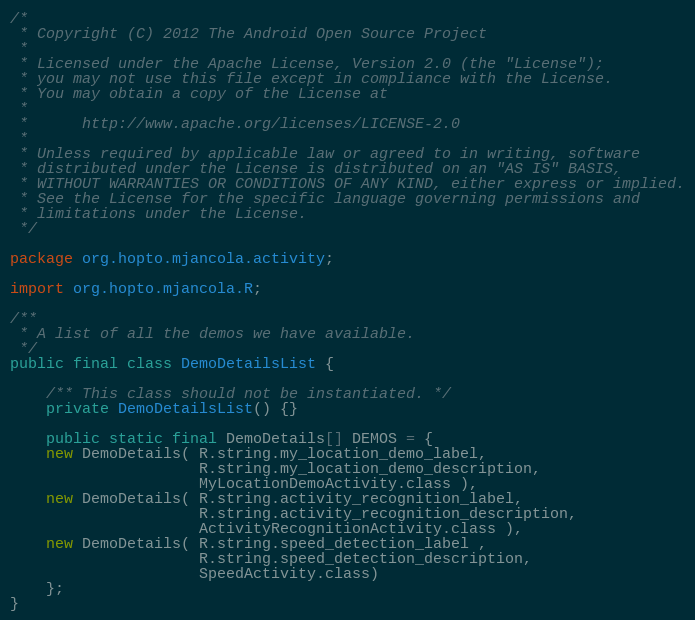<code> <loc_0><loc_0><loc_500><loc_500><_Java_>/*
 * Copyright (C) 2012 The Android Open Source Project
 *
 * Licensed under the Apache License, Version 2.0 (the "License");
 * you may not use this file except in compliance with the License.
 * You may obtain a copy of the License at
 *
 *      http://www.apache.org/licenses/LICENSE-2.0
 *
 * Unless required by applicable law or agreed to in writing, software
 * distributed under the License is distributed on an "AS IS" BASIS,
 * WITHOUT WARRANTIES OR CONDITIONS OF ANY KIND, either express or implied.
 * See the License for the specific language governing permissions and
 * limitations under the License.
 */

package org.hopto.mjancola.activity;

import org.hopto.mjancola.R;

/**
 * A list of all the demos we have available.
 */
public final class DemoDetailsList {

    /** This class should not be instantiated. */
    private DemoDetailsList() {}

    public static final DemoDetails[] DEMOS = {
    new DemoDetails( R.string.my_location_demo_label,
                     R.string.my_location_demo_description,
                     MyLocationDemoActivity.class ),
    new DemoDetails( R.string.activity_recognition_label,
                     R.string.activity_recognition_description,
                     ActivityRecognitionActivity.class ),
    new DemoDetails( R.string.speed_detection_label ,
                     R.string.speed_detection_description,
                     SpeedActivity.class)
    };
}

</code> 